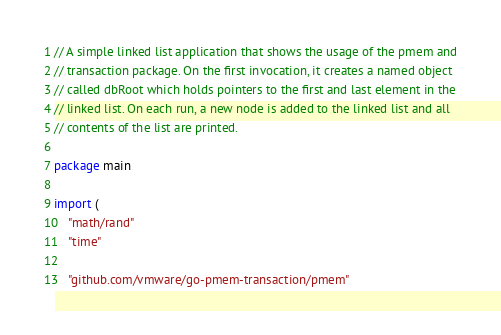Convert code to text. <code><loc_0><loc_0><loc_500><loc_500><_Go_>// A simple linked list application that shows the usage of the pmem and
// transaction package. On the first invocation, it creates a named object
// called dbRoot which holds pointers to the first and last element in the
// linked list. On each run, a new node is added to the linked list and all
// contents of the list are printed.

package main

import (
	"math/rand"
	"time"

	"github.com/vmware/go-pmem-transaction/pmem"</code> 